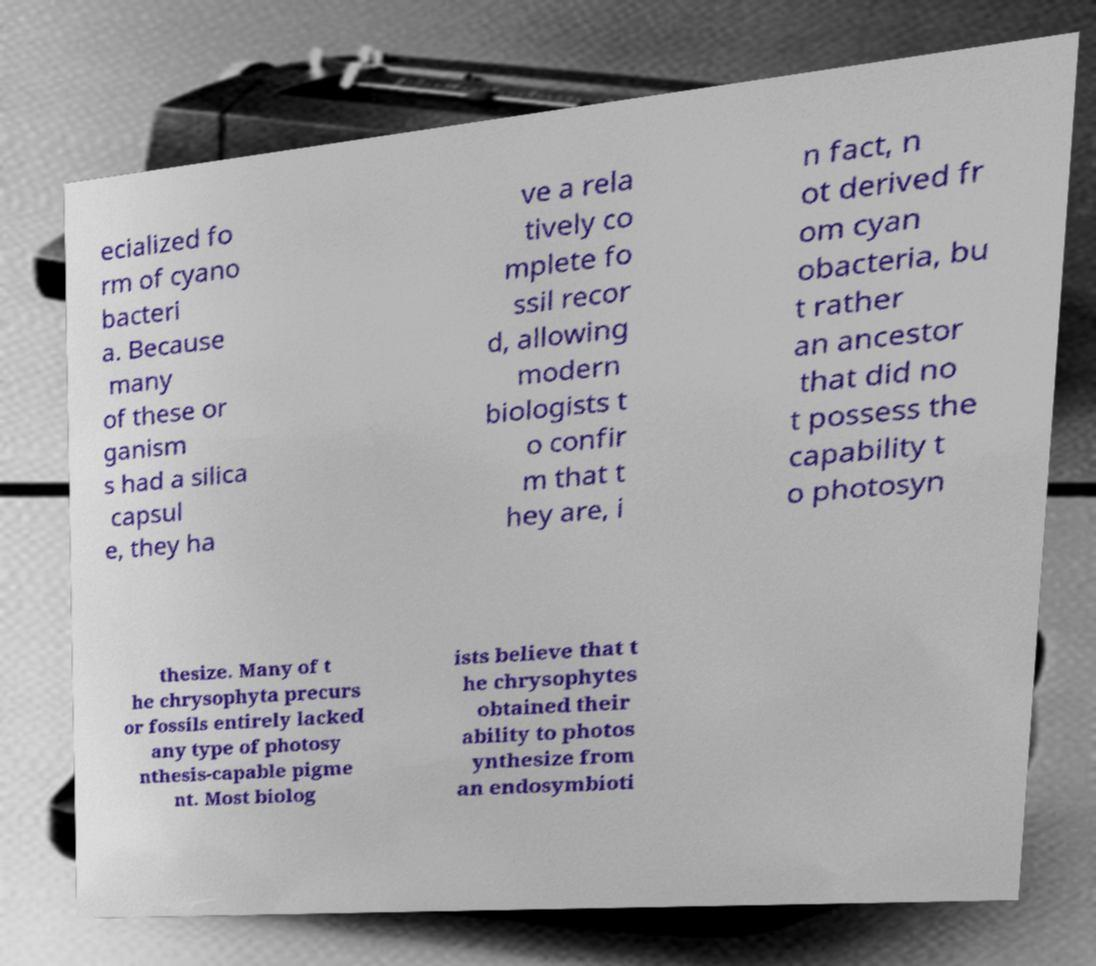Can you accurately transcribe the text from the provided image for me? ecialized fo rm of cyano bacteri a. Because many of these or ganism s had a silica capsul e, they ha ve a rela tively co mplete fo ssil recor d, allowing modern biologists t o confir m that t hey are, i n fact, n ot derived fr om cyan obacteria, bu t rather an ancestor that did no t possess the capability t o photosyn thesize. Many of t he chrysophyta precurs or fossils entirely lacked any type of photosy nthesis-capable pigme nt. Most biolog ists believe that t he chrysophytes obtained their ability to photos ynthesize from an endosymbioti 